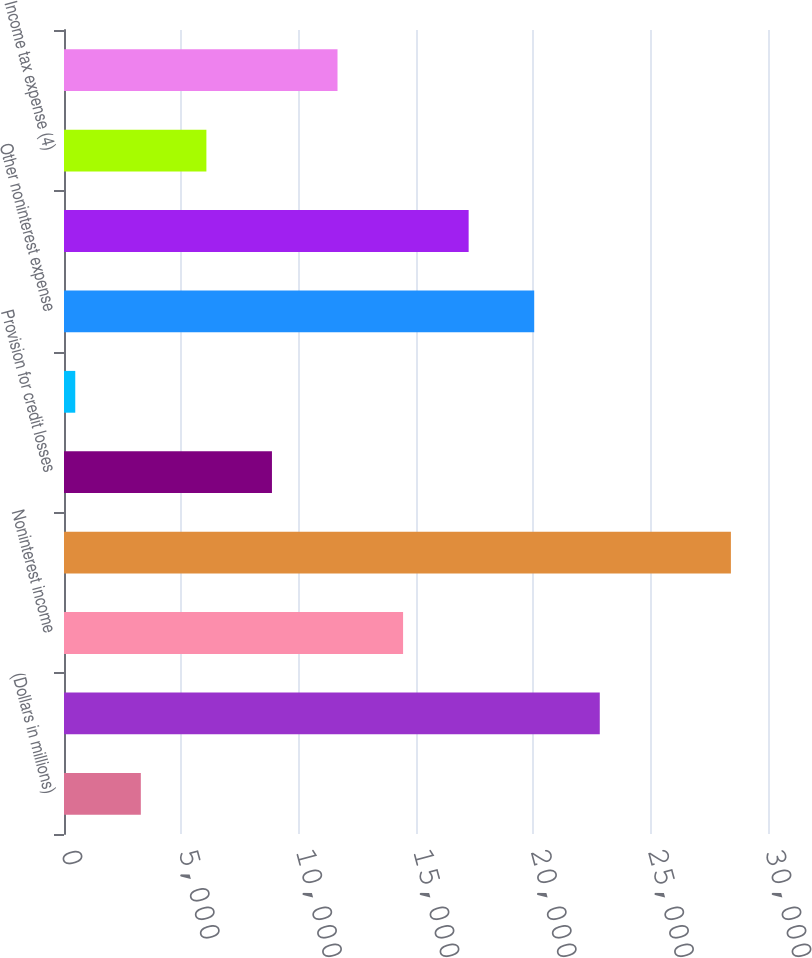Convert chart to OTSL. <chart><loc_0><loc_0><loc_500><loc_500><bar_chart><fcel>(Dollars in millions)<fcel>Net interest income (4)<fcel>Noninterest income<fcel>Total revenue net of interest<fcel>Provision for credit losses<fcel>Amortization of intangibles<fcel>Other noninterest expense<fcel>Income before income taxes<fcel>Income tax expense (4)<fcel>Net income<nl><fcel>3273.9<fcel>22831.2<fcel>14449.5<fcel>28419<fcel>8861.7<fcel>480<fcel>20037.3<fcel>17243.4<fcel>6067.8<fcel>11655.6<nl></chart> 